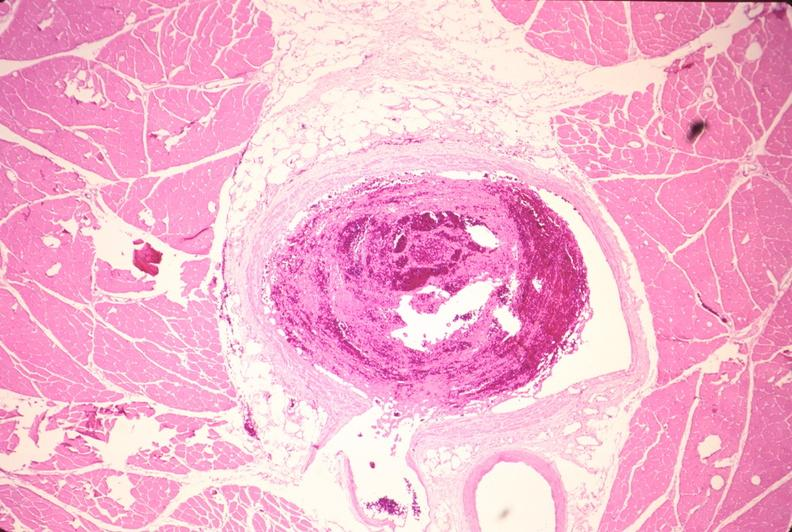where is this from?
Answer the question using a single word or phrase. Vasculature 